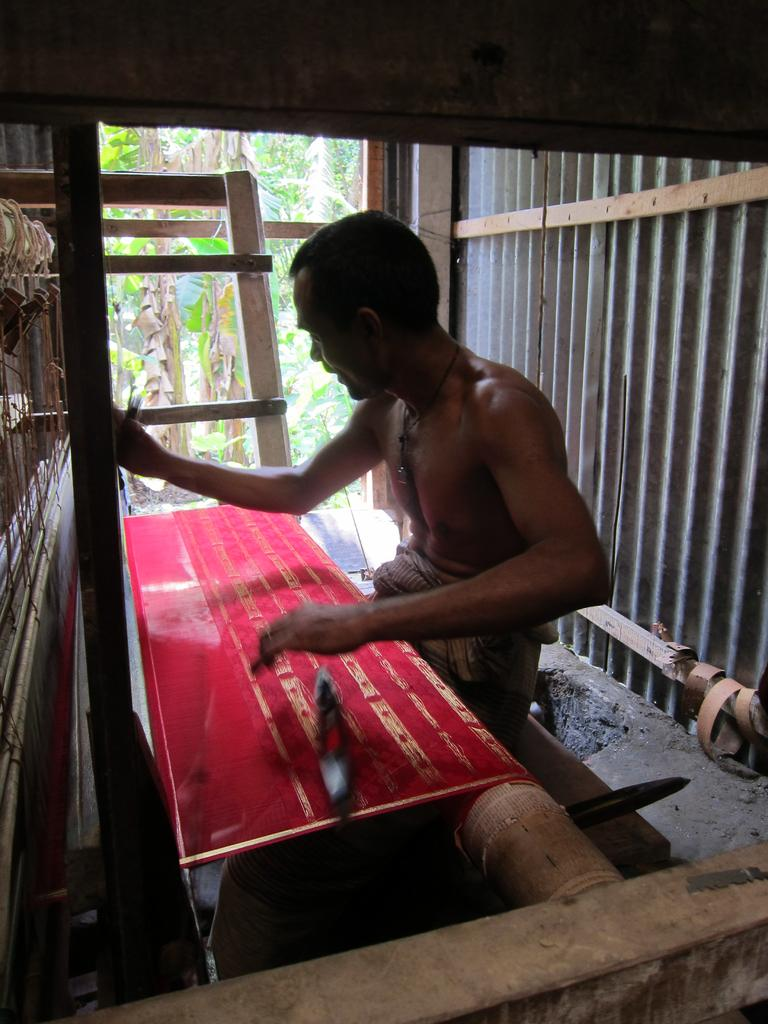Who is the main subject in the picture? There is a man in the middle of the picture. What is the man doing in the image? The man is weaving a red saree. What can be seen behind the man? There is a wooden wall behind the man. What architectural feature is located beside the man? There is a door beside the man. What is visible through the door? Trees are visible through the door. What type of suit is the man wearing in the image? The man is not wearing a suit in the image; he is weaving a red saree. How can the man experience quiet while weaving the saree? The image does not provide information about the man's experience or the level of noise in the environment, so it cannot be determined from the image. 